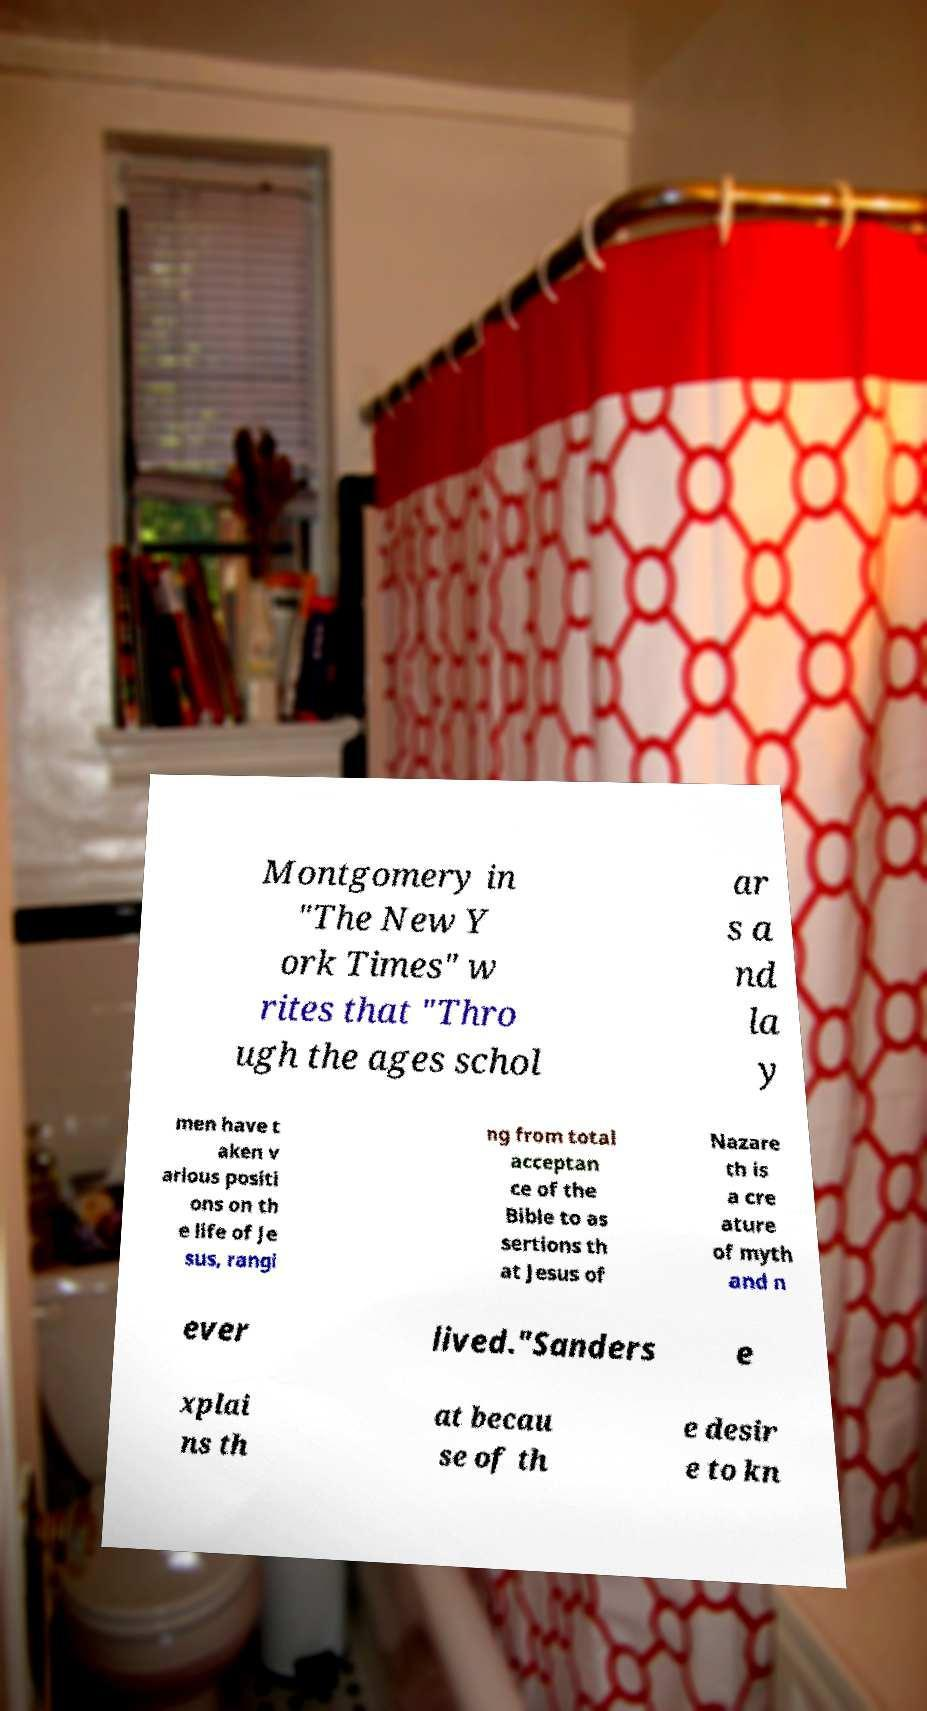I need the written content from this picture converted into text. Can you do that? Montgomery in "The New Y ork Times" w rites that "Thro ugh the ages schol ar s a nd la y men have t aken v arious positi ons on th e life of Je sus, rangi ng from total acceptan ce of the Bible to as sertions th at Jesus of Nazare th is a cre ature of myth and n ever lived."Sanders e xplai ns th at becau se of th e desir e to kn 